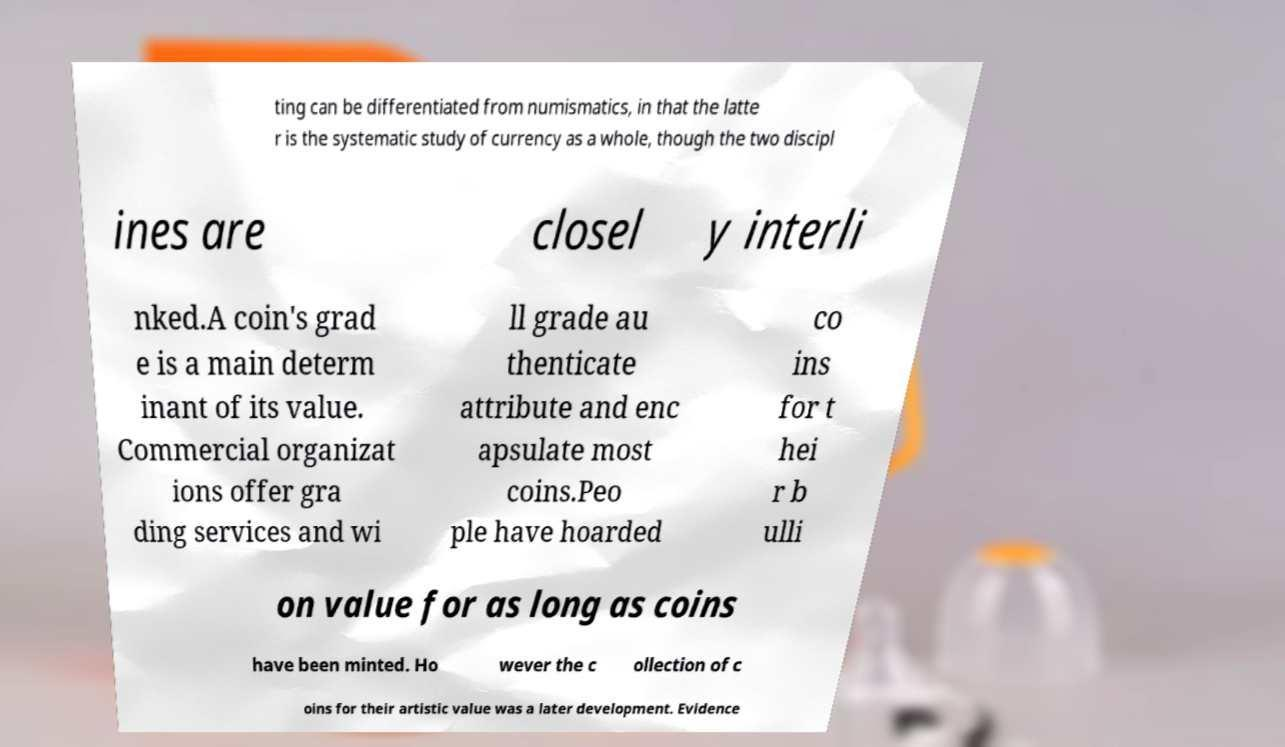Can you read and provide the text displayed in the image?This photo seems to have some interesting text. Can you extract and type it out for me? ting can be differentiated from numismatics, in that the latte r is the systematic study of currency as a whole, though the two discipl ines are closel y interli nked.A coin's grad e is a main determ inant of its value. Commercial organizat ions offer gra ding services and wi ll grade au thenticate attribute and enc apsulate most coins.Peo ple have hoarded co ins for t hei r b ulli on value for as long as coins have been minted. Ho wever the c ollection of c oins for their artistic value was a later development. Evidence 